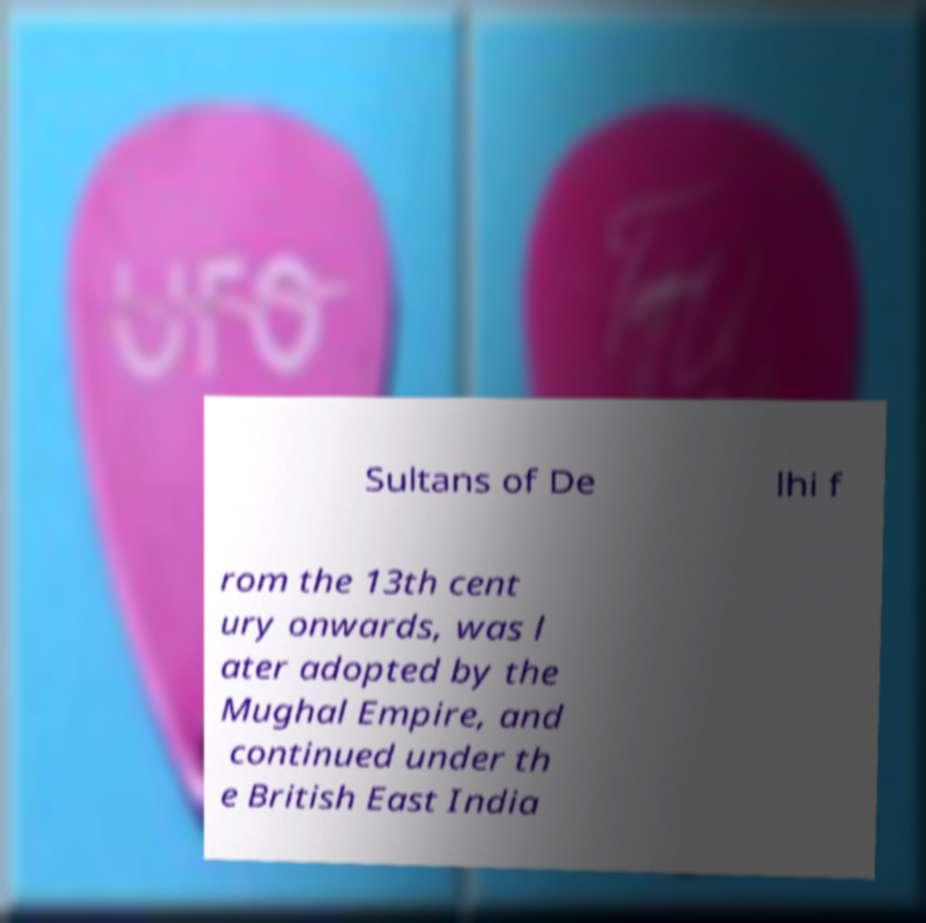Please identify and transcribe the text found in this image. Sultans of De lhi f rom the 13th cent ury onwards, was l ater adopted by the Mughal Empire, and continued under th e British East India 